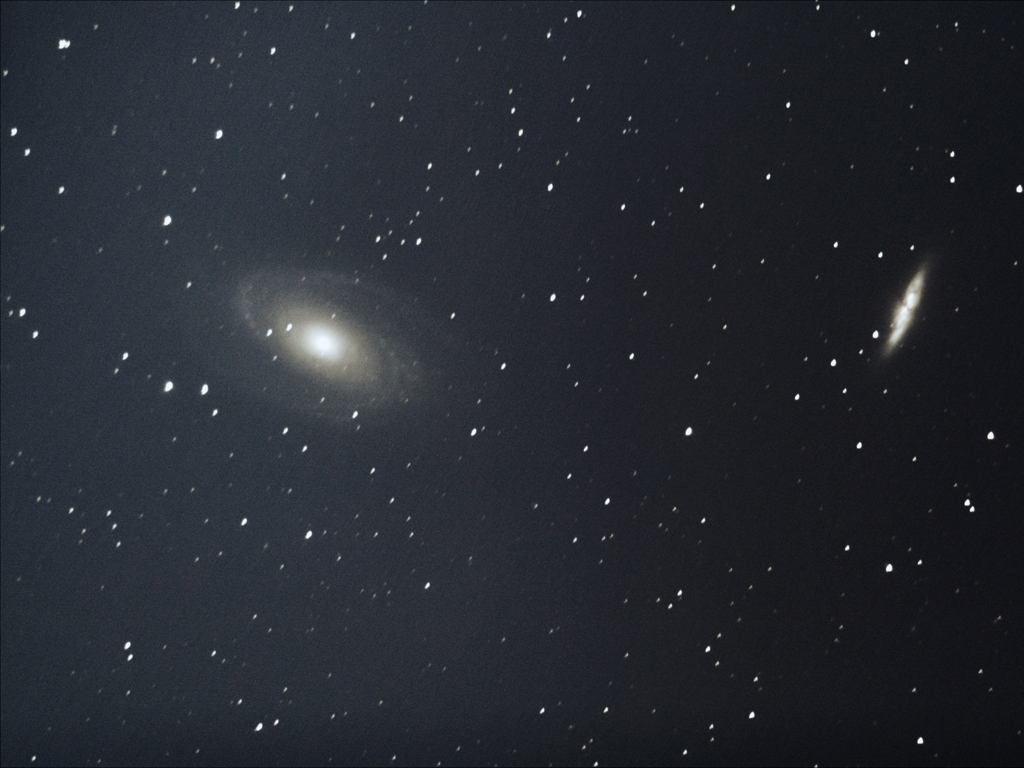Does the main subject have significant texture details? The main subject, which appears to be a distant galaxy, does exhibit significant texture details. The spiral arms and dust lanes present within the galaxy structure are indicative of texture, providing depth and complexity to the observation. 